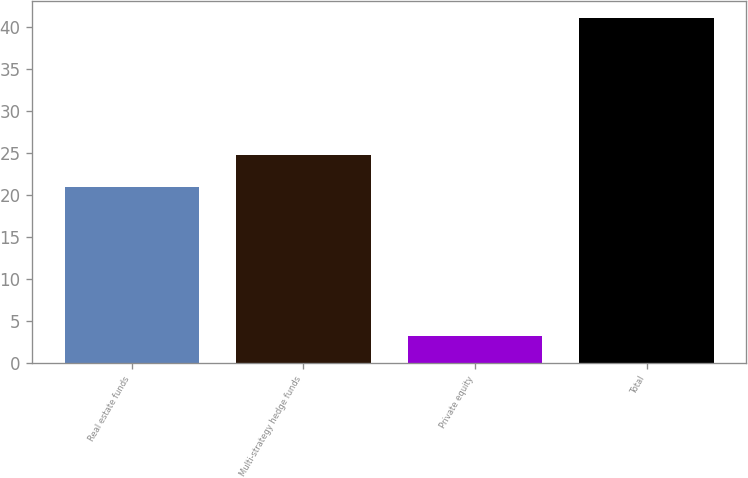Convert chart. <chart><loc_0><loc_0><loc_500><loc_500><bar_chart><fcel>Real estate funds<fcel>Multi-strategy hedge funds<fcel>Private equity<fcel>Total<nl><fcel>21<fcel>24.77<fcel>3.3<fcel>41<nl></chart> 